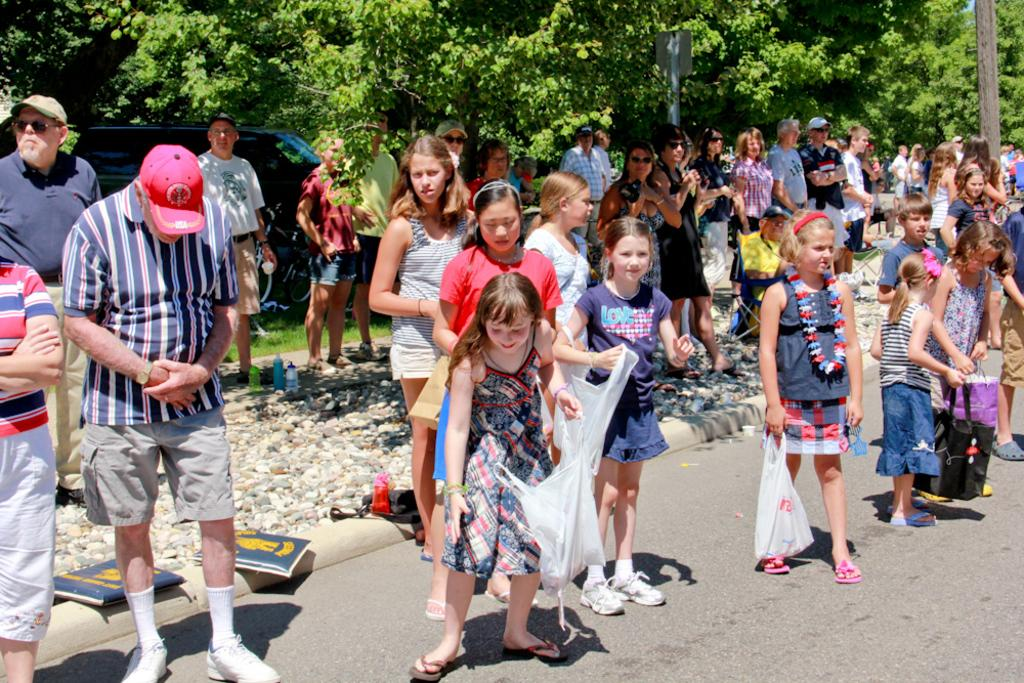What is happening in the middle of the image? There are people standing in the middle of the image. What are the people holding in their hands? The people are holding something in their hands. What can be seen in the background of the image? There are vehicles, trees, and bicycles visible in the background. What type of leaf is being used as a nose by one of the people in the image? There is no leaf or person using a leaf as a nose in the image. 